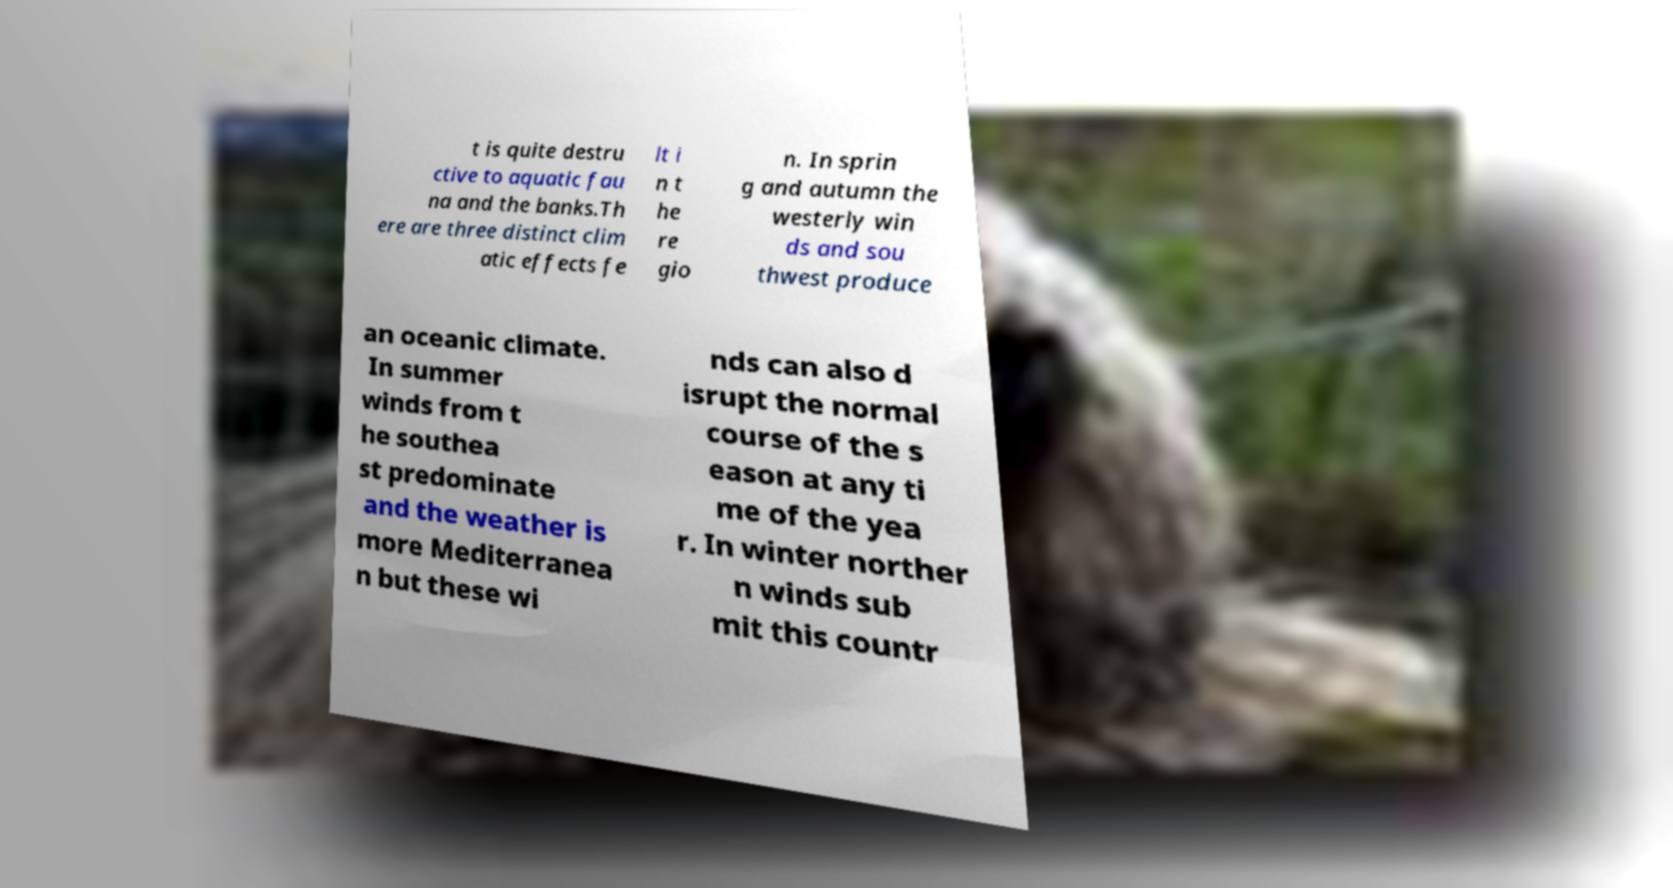Please read and relay the text visible in this image. What does it say? t is quite destru ctive to aquatic fau na and the banks.Th ere are three distinct clim atic effects fe lt i n t he re gio n. In sprin g and autumn the westerly win ds and sou thwest produce an oceanic climate. In summer winds from t he southea st predominate and the weather is more Mediterranea n but these wi nds can also d isrupt the normal course of the s eason at any ti me of the yea r. In winter norther n winds sub mit this countr 